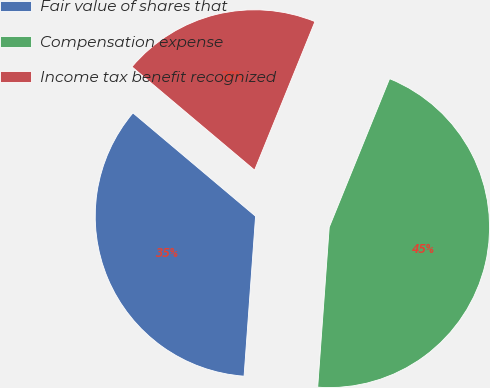Convert chart. <chart><loc_0><loc_0><loc_500><loc_500><pie_chart><fcel>Fair value of shares that<fcel>Compensation expense<fcel>Income tax benefit recognized<nl><fcel>35.0%<fcel>45.0%<fcel>20.0%<nl></chart> 